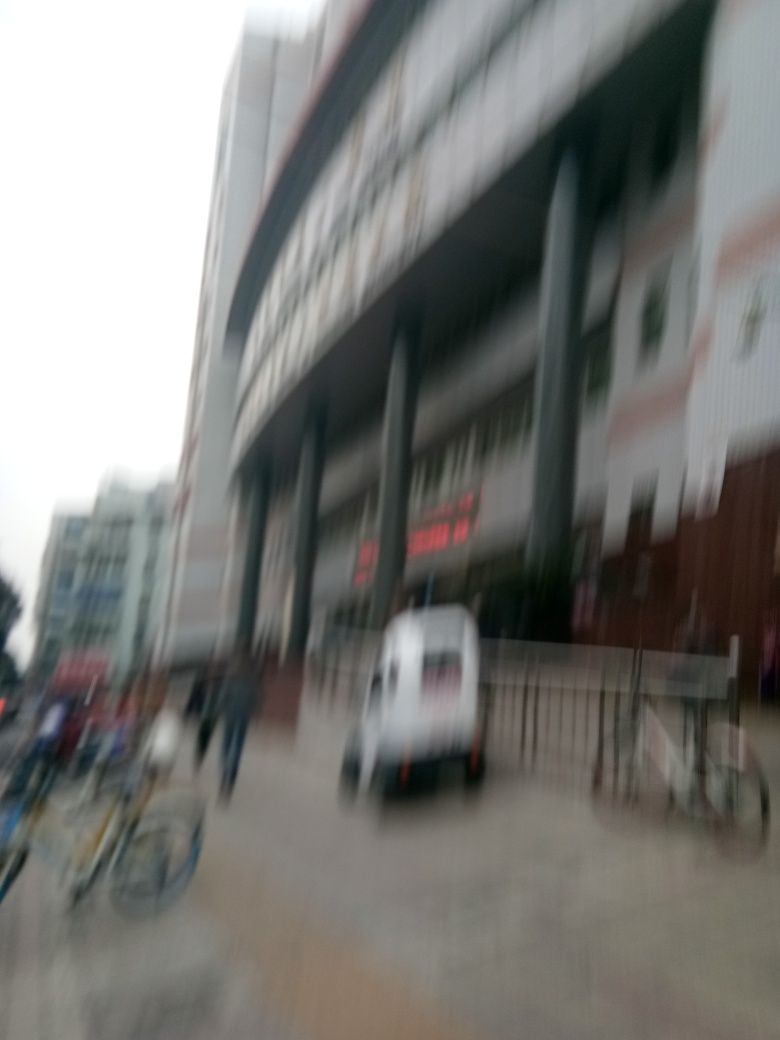Could this image's quality be improved with editing software? While some clarity might be restored with sharpening tools, the extent of the blurriness means significant details are lost, which limits the improvements that software can achieve. A better option would usually be to retake the photo with proper focus and stability. 